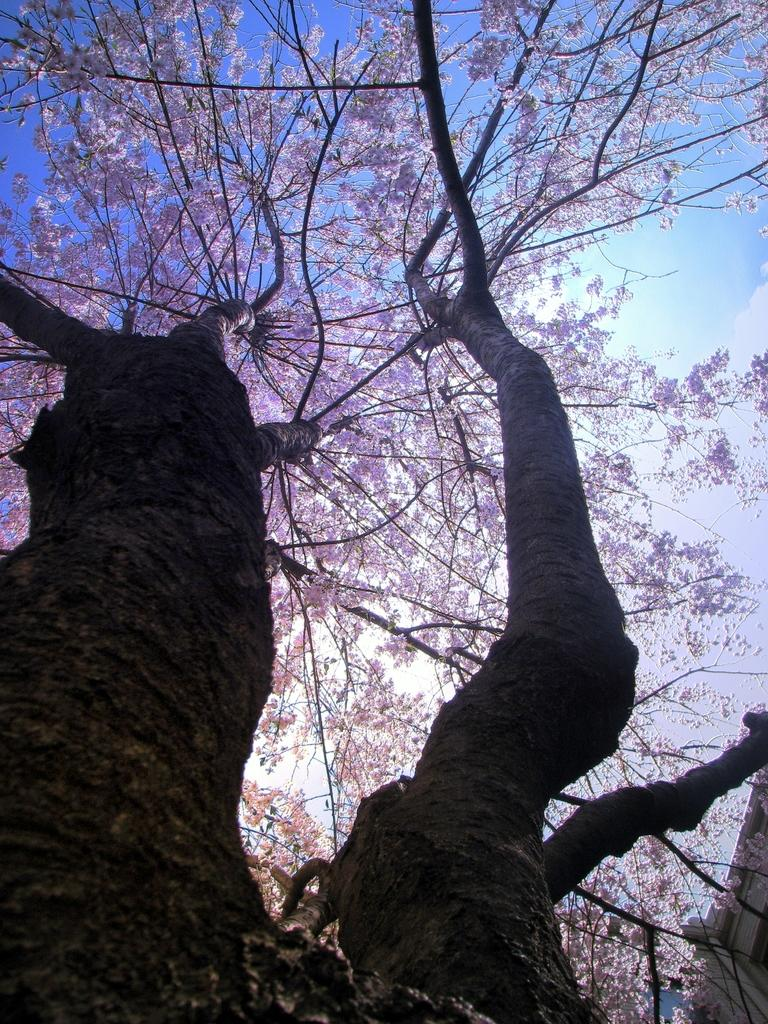What is the main subject of the image? The main subject of the image is a tree. What is unique about the tree's appearance? The tree has violet-colored leaves. What can be seen in the background of the image? There is sky visible in the background of the image. How many boys are holding a pan in the image? There are no boys or pans present in the image; it features a tree with violet-colored leaves. 